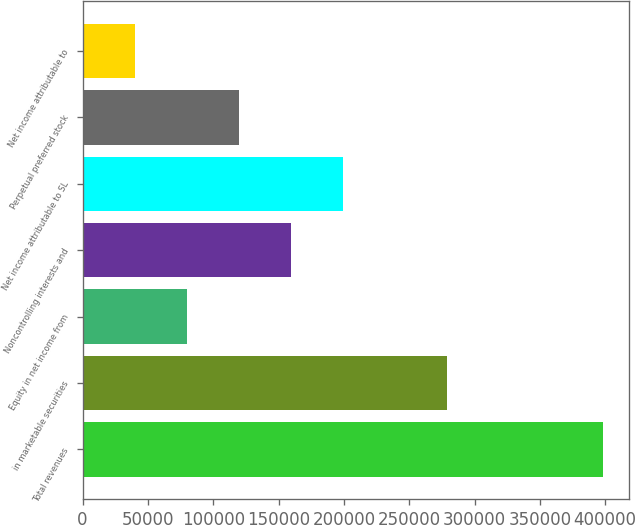Convert chart to OTSL. <chart><loc_0><loc_0><loc_500><loc_500><bar_chart><fcel>Total revenues<fcel>in marketable securities<fcel>Equity in net income from<fcel>Noncontrolling interests and<fcel>Net income attributable to SL<fcel>Perpetual preferred stock<fcel>Net income attributable to<nl><fcel>398150<fcel>278705<fcel>79630.1<fcel>159260<fcel>199075<fcel>119445<fcel>39815.1<nl></chart> 